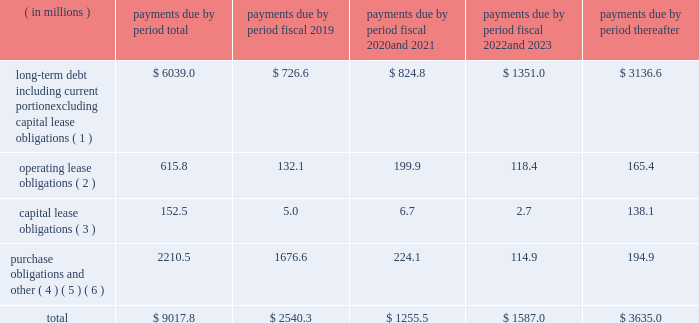Contractual obligations we summarize our enforceable and legally binding contractual obligations at september 30 , 2018 , and the effect these obligations are expected to have on our liquidity and cash flow in future periods in the table .
Certain amounts in this table are based on management fffds estimates and assumptions about these obligations , including their duration , the possibility of renewal , anticipated actions by third parties and other factors , including estimated minimum pension plan contributions and estimated benefit payments related to postretirement obligations , supplemental retirement plans and deferred compensation plans .
Because these estimates and assumptions are subjective , the enforceable and legally binding obligations we actually pay in future periods may vary from those presented in the table. .
( 1 ) includes only principal payments owed on our debt assuming that all of our long-term debt will be held to maturity , excluding scheduled payments .
We have excluded $ 205.2 million of fair value of debt step-up , deferred financing costs and unamortized bond discounts from the table to arrive at actual debt obligations .
See fffdnote 13 .
Debt fffd fffd of the notes to consolidated financial statements for information on the interest rates that apply to our various debt instruments .
( 2 ) see fffdnote 14 .
Operating leases fffd of the notes to consolidated financial statements for additional information .
( 3 ) the fair value step-up of $ 18.5 million is excluded .
See fffdnote 13 .
Debt fffd fffd capital lease and other indebtednesstt fffd of the notes to consolidated financial statements for additional information .
( 4 ) purchase obligations include agreements to purchase goods or services that are enforceable and legally binding and that specify all significant terms , including : fixed or minimum quantities to be purchased ; fixed , minimum or variable price provision ; and the approximate timing of the transaction .
Purchase obligations exclude agreements that are cancelable without penalty .
( 5 ) we have included in the table future estimated minimum pension plan contributions and estimated benefit payments related to postretirement obligations , supplemental retirement plans and deferred compensation plans .
Our estimates are based on factors , such as discount rates and expected returns on plan assets .
Future contributions are subject to changes in our underfunded status based on factors such as investment performance , discount rates , returns on plan assets and changes in legislation .
It is possible that our assumptions may change , actual market performance may vary or we may decide to contribute different amounts .
We have excluded $ 247.8 million of multiemployer pension plan withdrawal liabilities recorded as of september 30 , 2018 due to lack of definite payout terms for certain of the obligations .
See fffdnote 4 .
Retirement plans fffd multiemployer plans fffd of the notes to consolidated financial statements for additional information .
( 6 ) we have not included the following items in the table : fffd an item labeled fffdother long-term liabilities fffd reflected on our consolidated balance sheet because these liabilities do not have a definite pay-out scheme .
Fffd $ 158.4 million from the line item fffdpurchase obligations and other fffd for certain provisions of the financial accounting standards board fffds ( fffdfasb fffd ) accounting standards codification ( fffdasc fffd ) 740 , fffdincome taxes fffd associated with liabilities for uncertain tax positions due to the uncertainty as to the amount and timing of payment , if any .
In addition to the enforceable and legally binding obligations presented in the table above , we have other obligations for goods and services and raw materials entered into in the normal course of business .
These contracts , however , are subject to change based on our business decisions .
Expenditures for environmental compliance see item 1 .
Fffdbusiness fffd fffd governmental regulation fffd environmental and other matters fffd , fffdbusiness fffd fffd governmental regulation fffd cercla and other remediation costs fffd , and fffd fffdbusiness fffd fffd governmental regulation fffd climate change fffd for a discussion of our expenditures for environmental compliance. .
What was the percent of the total long-term debt including current portion excluding capital lease obligations that was due in 2019? 
Computations: (726.6 / 6039.0)
Answer: 0.12032. 